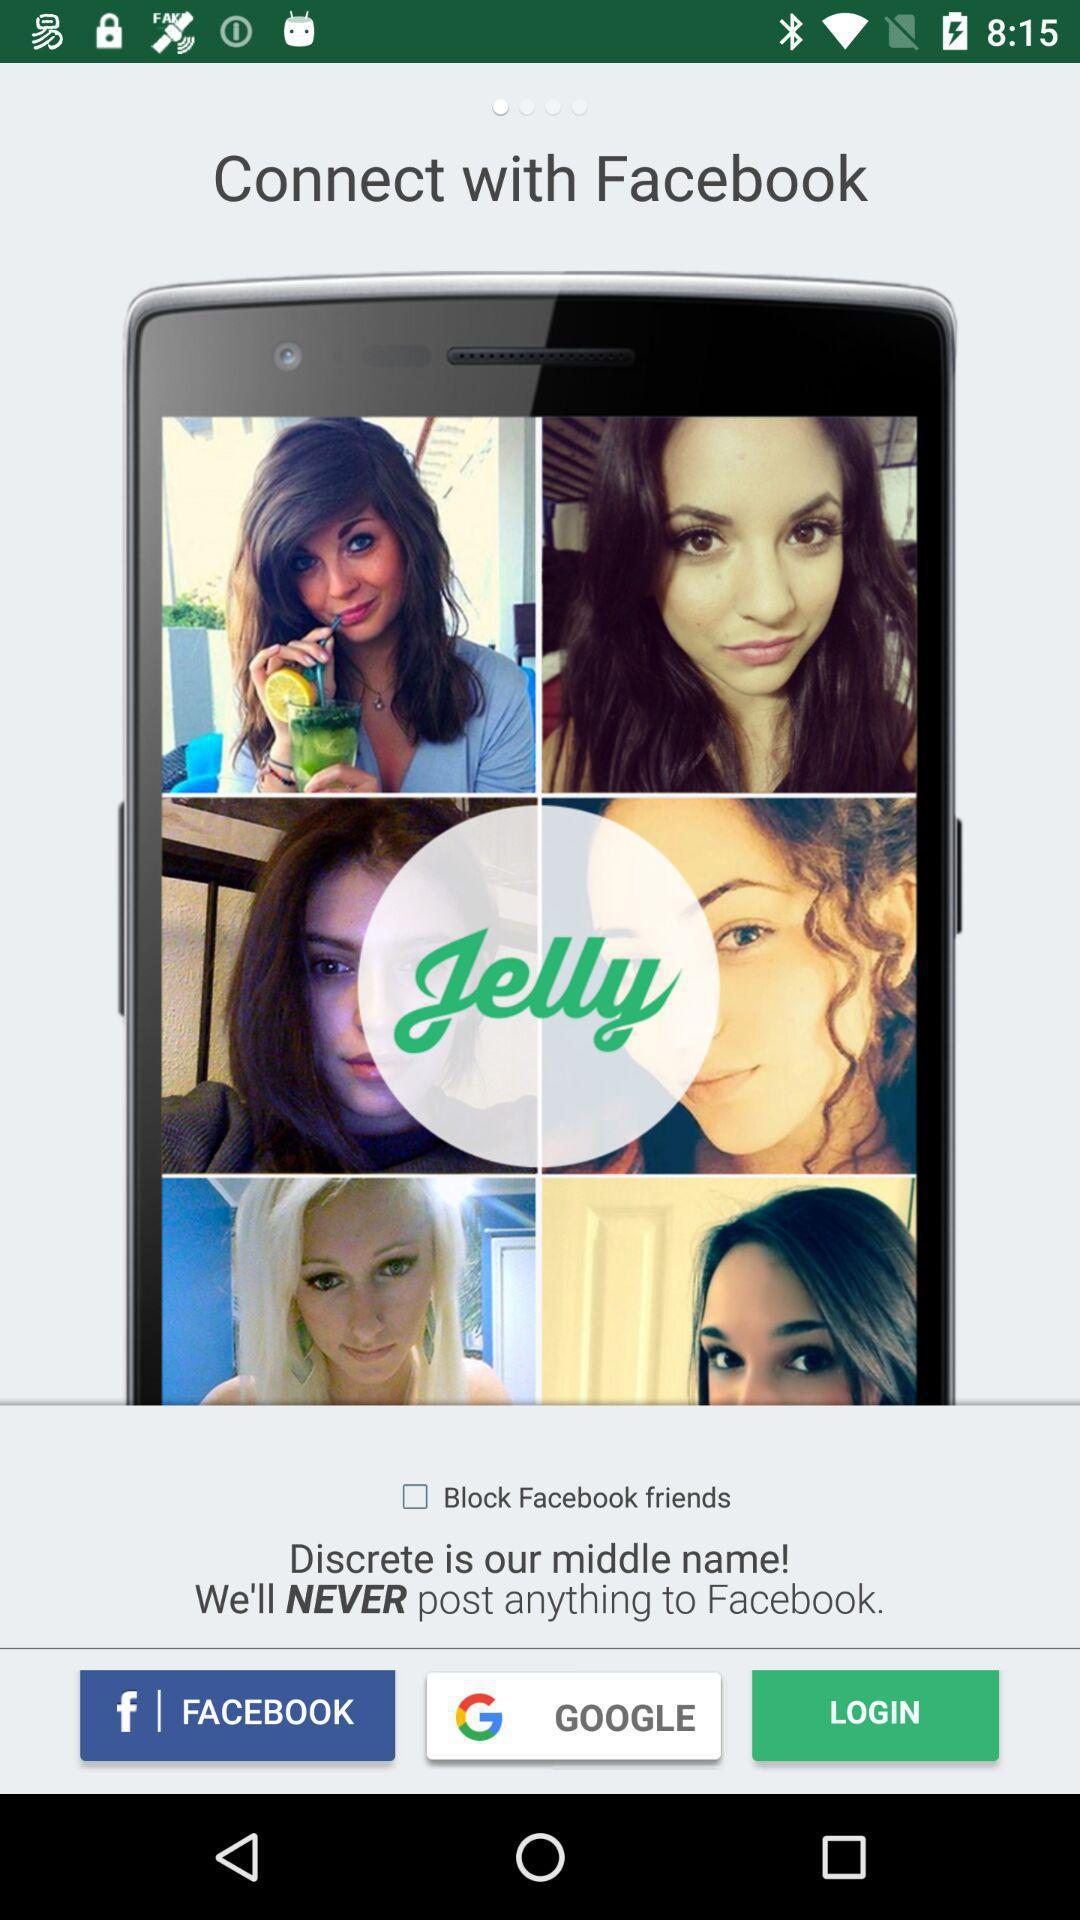Which version of "Jelly" is this?
When the provided information is insufficient, respond with <no answer>. <no answer> 